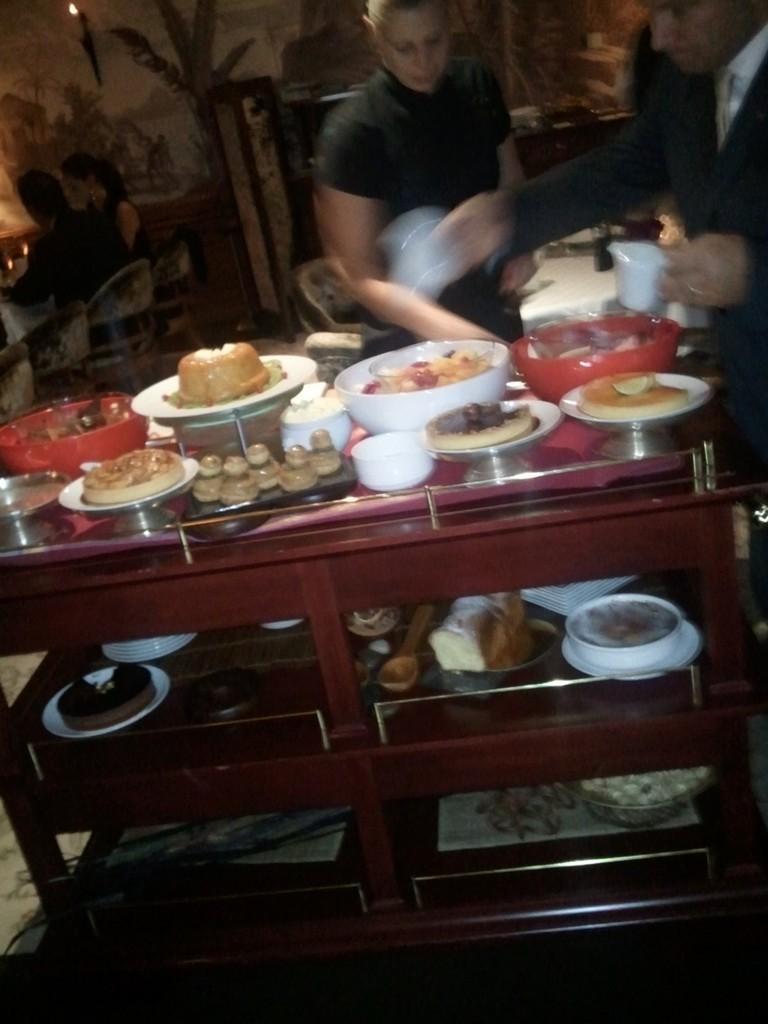Could you give a brief overview of what you see in this image? In this image we can see a group of objects on a table. Behind the table, we can see two persons. On the right side, we can see a person holding objects. Behind the persons we can see a wall. In the top left, we can see two persons sitting on chairs. 